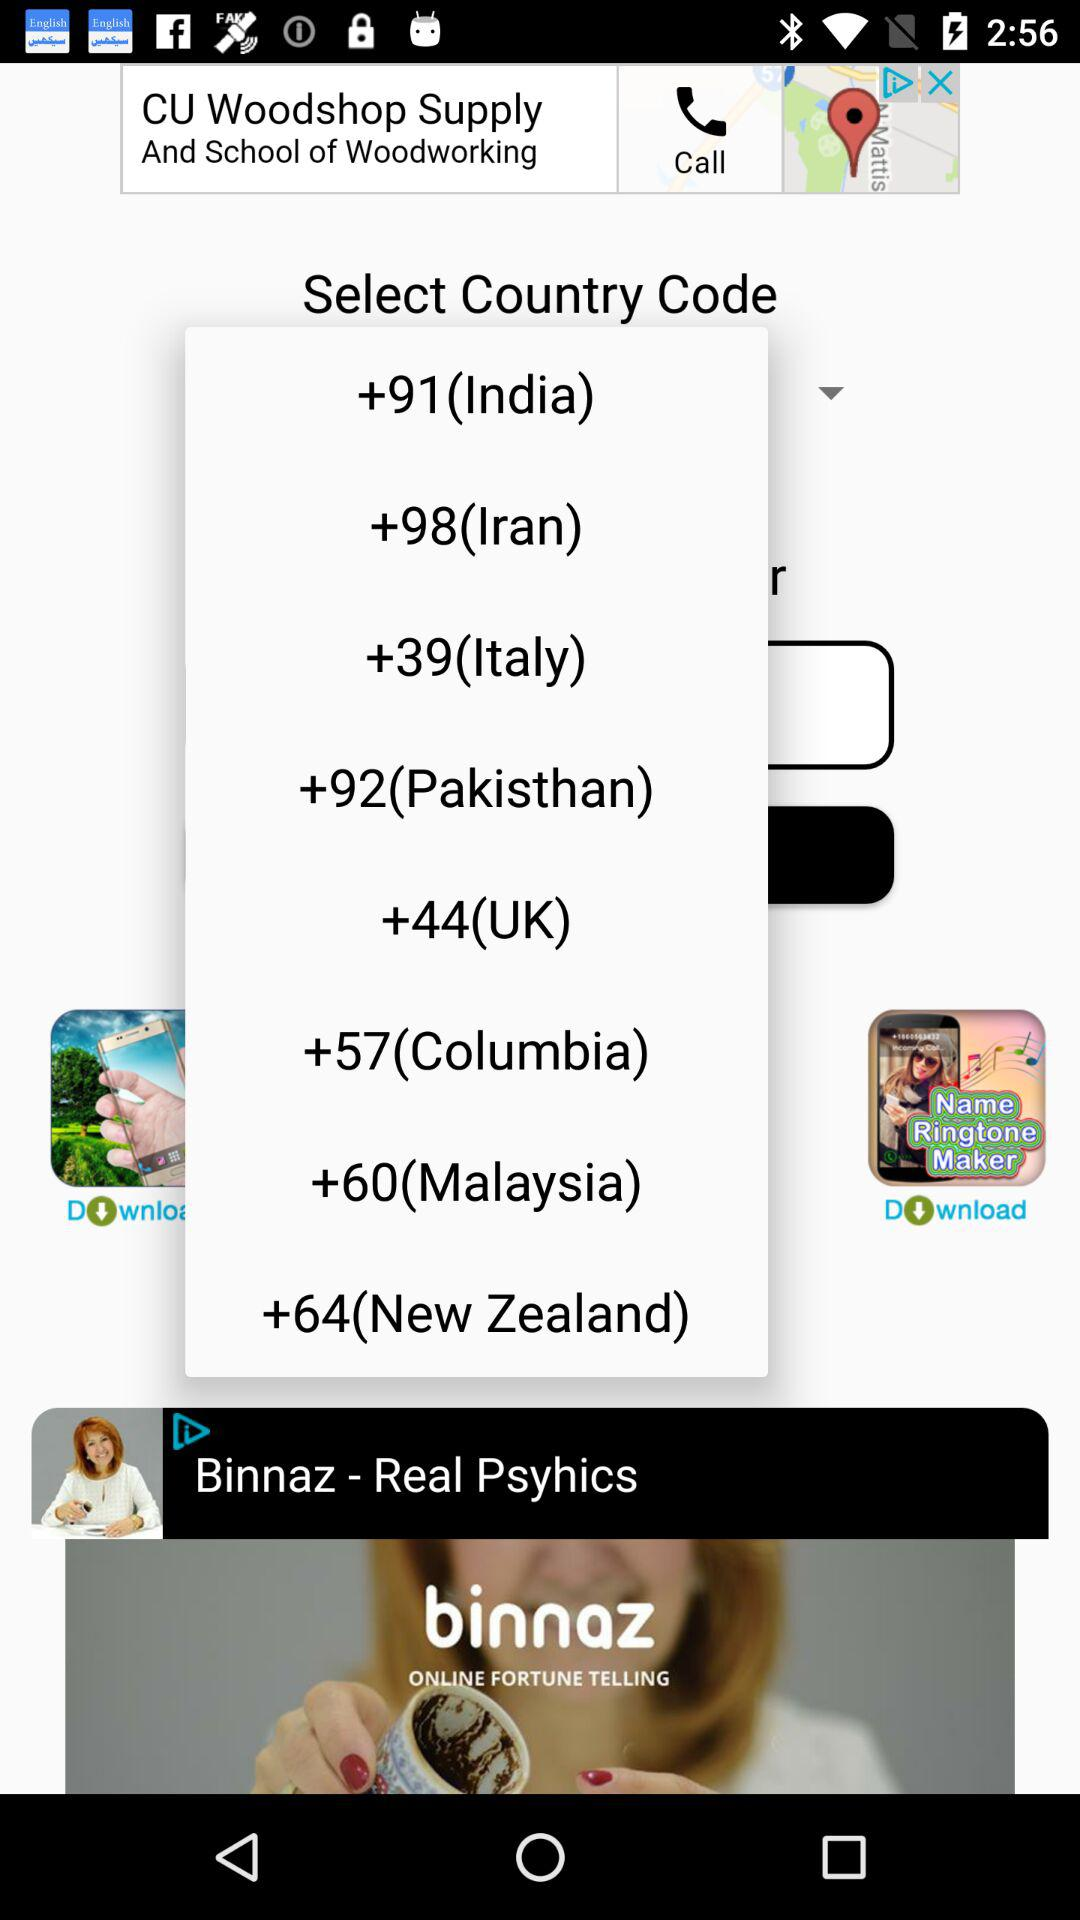What is the country code for the UK? The country code for the UK is +44. 